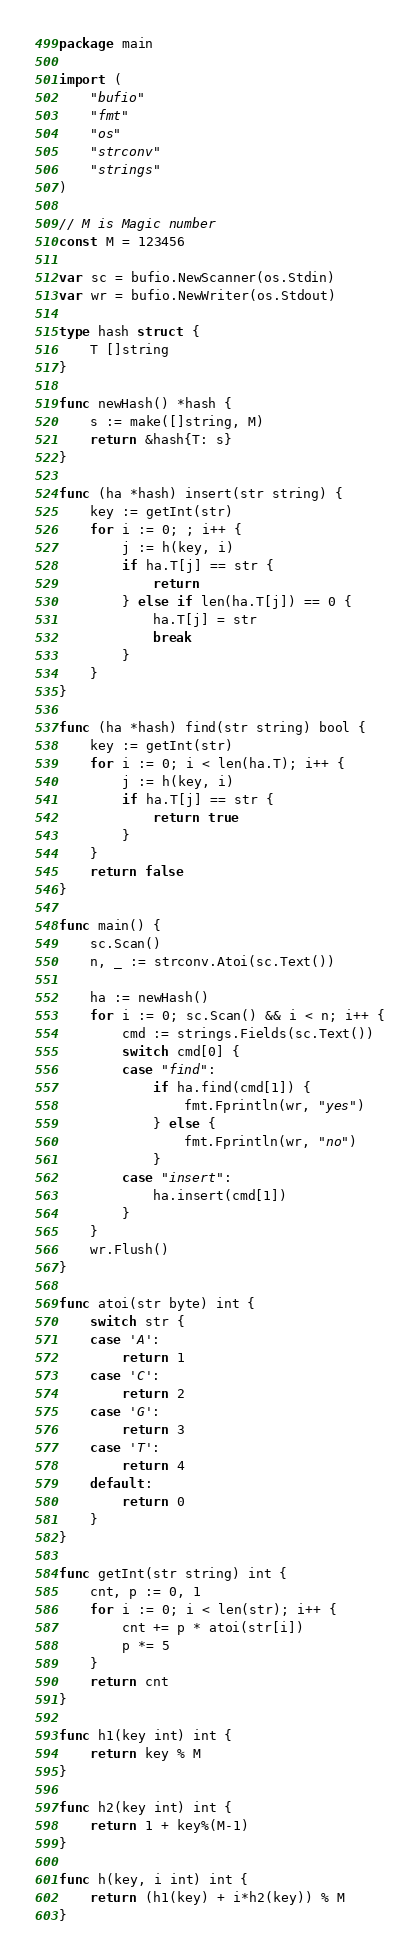Convert code to text. <code><loc_0><loc_0><loc_500><loc_500><_Go_>package main

import (
	"bufio"
	"fmt"
	"os"
	"strconv"
	"strings"
)

// M is Magic number
const M = 123456

var sc = bufio.NewScanner(os.Stdin)
var wr = bufio.NewWriter(os.Stdout)

type hash struct {
	T []string
}

func newHash() *hash {
	s := make([]string, M)
	return &hash{T: s}
}

func (ha *hash) insert(str string) {
	key := getInt(str)
	for i := 0; ; i++ {
		j := h(key, i)
		if ha.T[j] == str {
			return
		} else if len(ha.T[j]) == 0 {
			ha.T[j] = str
			break
		}
	}
}

func (ha *hash) find(str string) bool {
	key := getInt(str)
	for i := 0; i < len(ha.T); i++ {
		j := h(key, i)
		if ha.T[j] == str {
			return true
		}
	}
	return false
}

func main() {
	sc.Scan()
	n, _ := strconv.Atoi(sc.Text())

	ha := newHash()
	for i := 0; sc.Scan() && i < n; i++ {
		cmd := strings.Fields(sc.Text())
		switch cmd[0] {
		case "find":
			if ha.find(cmd[1]) {
				fmt.Fprintln(wr, "yes")
			} else {
				fmt.Fprintln(wr, "no")
			}
		case "insert":
			ha.insert(cmd[1])
		}
	}
	wr.Flush()
}

func atoi(str byte) int {
	switch str {
	case 'A':
		return 1
	case 'C':
		return 2
	case 'G':
		return 3
	case 'T':
		return 4
	default:
		return 0
	}
}

func getInt(str string) int {
	cnt, p := 0, 1
	for i := 0; i < len(str); i++ {
		cnt += p * atoi(str[i])
		p *= 5
	}
	return cnt
}

func h1(key int) int {
	return key % M
}

func h2(key int) int {
	return 1 + key%(M-1)
}

func h(key, i int) int {
	return (h1(key) + i*h2(key)) % M
}

</code> 